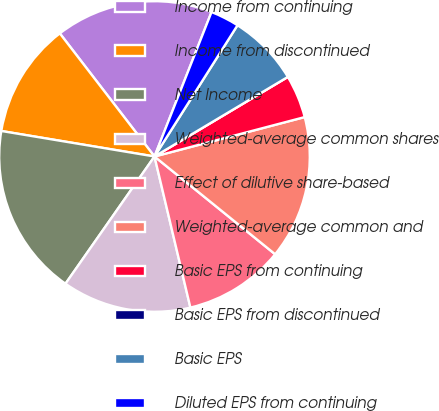<chart> <loc_0><loc_0><loc_500><loc_500><pie_chart><fcel>Income from continuing<fcel>Income from discontinued<fcel>Net Income<fcel>Weighted-average common shares<fcel>Effect of dilutive share-based<fcel>Weighted-average common and<fcel>Basic EPS from continuing<fcel>Basic EPS from discontinued<fcel>Basic EPS<fcel>Diluted EPS from continuing<nl><fcel>16.42%<fcel>11.94%<fcel>17.91%<fcel>13.43%<fcel>10.45%<fcel>14.92%<fcel>4.48%<fcel>0.0%<fcel>7.46%<fcel>2.99%<nl></chart> 